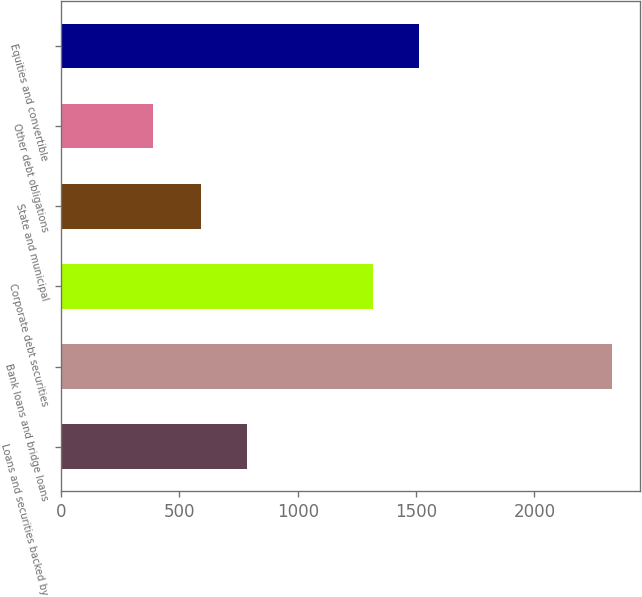<chart> <loc_0><loc_0><loc_500><loc_500><bar_chart><fcel>Loans and securities backed by<fcel>Bank loans and bridge loans<fcel>Corporate debt securities<fcel>State and municipal<fcel>Other debt obligations<fcel>Equities and convertible<nl><fcel>785.1<fcel>2329<fcel>1318.1<fcel>591<fcel>388<fcel>1512.2<nl></chart> 